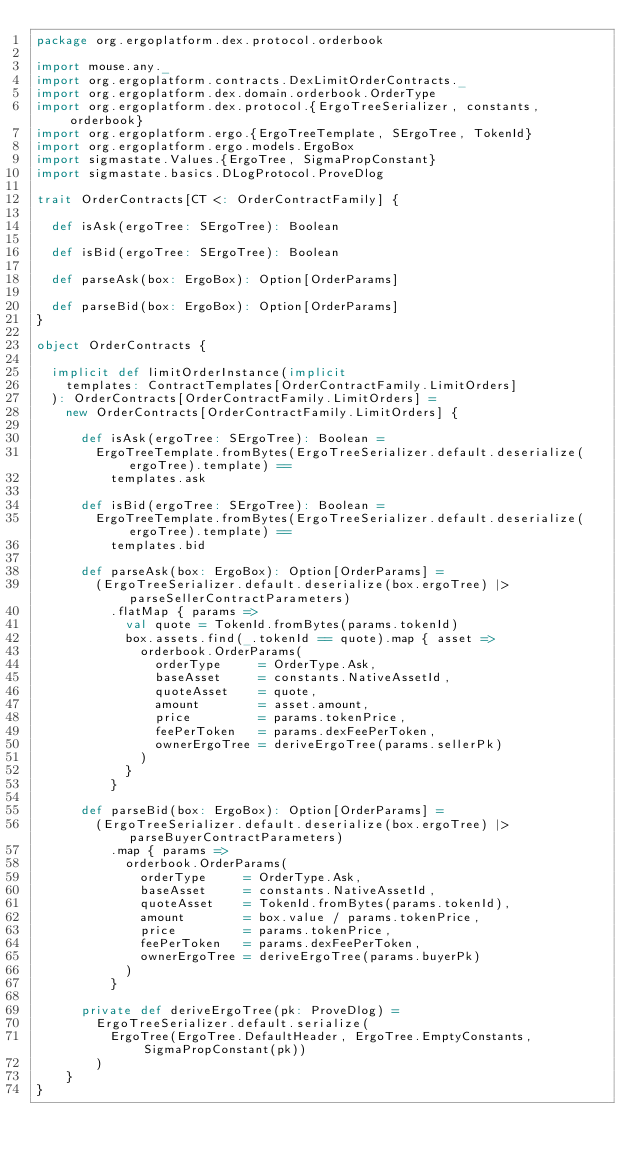<code> <loc_0><loc_0><loc_500><loc_500><_Scala_>package org.ergoplatform.dex.protocol.orderbook

import mouse.any._
import org.ergoplatform.contracts.DexLimitOrderContracts._
import org.ergoplatform.dex.domain.orderbook.OrderType
import org.ergoplatform.dex.protocol.{ErgoTreeSerializer, constants, orderbook}
import org.ergoplatform.ergo.{ErgoTreeTemplate, SErgoTree, TokenId}
import org.ergoplatform.ergo.models.ErgoBox
import sigmastate.Values.{ErgoTree, SigmaPropConstant}
import sigmastate.basics.DLogProtocol.ProveDlog

trait OrderContracts[CT <: OrderContractFamily] {

  def isAsk(ergoTree: SErgoTree): Boolean

  def isBid(ergoTree: SErgoTree): Boolean

  def parseAsk(box: ErgoBox): Option[OrderParams]

  def parseBid(box: ErgoBox): Option[OrderParams]
}

object OrderContracts {

  implicit def limitOrderInstance(implicit
    templates: ContractTemplates[OrderContractFamily.LimitOrders]
  ): OrderContracts[OrderContractFamily.LimitOrders] =
    new OrderContracts[OrderContractFamily.LimitOrders] {

      def isAsk(ergoTree: SErgoTree): Boolean =
        ErgoTreeTemplate.fromBytes(ErgoTreeSerializer.default.deserialize(ergoTree).template) ==
          templates.ask

      def isBid(ergoTree: SErgoTree): Boolean =
        ErgoTreeTemplate.fromBytes(ErgoTreeSerializer.default.deserialize(ergoTree).template) ==
          templates.bid

      def parseAsk(box: ErgoBox): Option[OrderParams] =
        (ErgoTreeSerializer.default.deserialize(box.ergoTree) |> parseSellerContractParameters)
          .flatMap { params =>
            val quote = TokenId.fromBytes(params.tokenId)
            box.assets.find(_.tokenId == quote).map { asset =>
              orderbook.OrderParams(
                orderType     = OrderType.Ask,
                baseAsset     = constants.NativeAssetId,
                quoteAsset    = quote,
                amount        = asset.amount,
                price         = params.tokenPrice,
                feePerToken   = params.dexFeePerToken,
                ownerErgoTree = deriveErgoTree(params.sellerPk)
              )
            }
          }

      def parseBid(box: ErgoBox): Option[OrderParams] =
        (ErgoTreeSerializer.default.deserialize(box.ergoTree) |> parseBuyerContractParameters)
          .map { params =>
            orderbook.OrderParams(
              orderType     = OrderType.Ask,
              baseAsset     = constants.NativeAssetId,
              quoteAsset    = TokenId.fromBytes(params.tokenId),
              amount        = box.value / params.tokenPrice,
              price         = params.tokenPrice,
              feePerToken   = params.dexFeePerToken,
              ownerErgoTree = deriveErgoTree(params.buyerPk)
            )
          }

      private def deriveErgoTree(pk: ProveDlog) =
        ErgoTreeSerializer.default.serialize(
          ErgoTree(ErgoTree.DefaultHeader, ErgoTree.EmptyConstants, SigmaPropConstant(pk))
        )
    }
}
</code> 